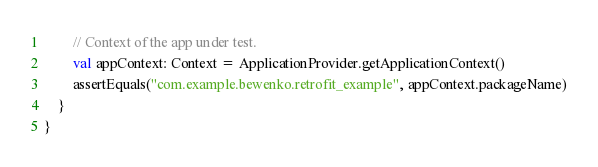<code> <loc_0><loc_0><loc_500><loc_500><_Kotlin_>        // Context of the app under test.
        val appContext: Context = ApplicationProvider.getApplicationContext()
        assertEquals("com.example.bewenko.retrofit_example", appContext.packageName)
    }
}
</code> 